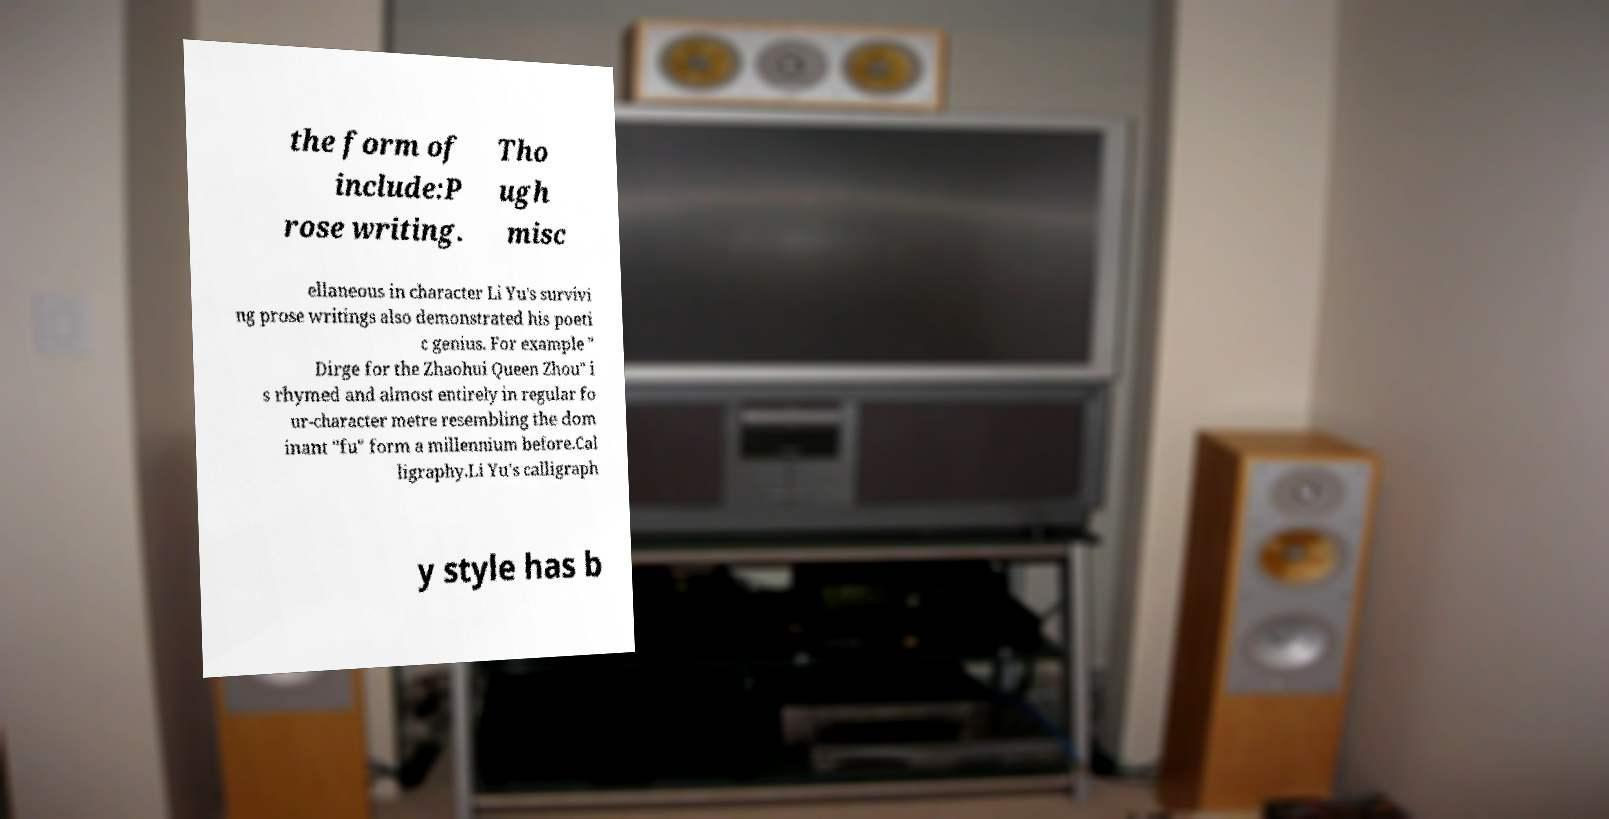There's text embedded in this image that I need extracted. Can you transcribe it verbatim? the form of include:P rose writing. Tho ugh misc ellaneous in character Li Yu's survivi ng prose writings also demonstrated his poeti c genius. For example " Dirge for the Zhaohui Queen Zhou" i s rhymed and almost entirely in regular fo ur-character metre resembling the dom inant "fu" form a millennium before.Cal ligraphy.Li Yu's calligraph y style has b 